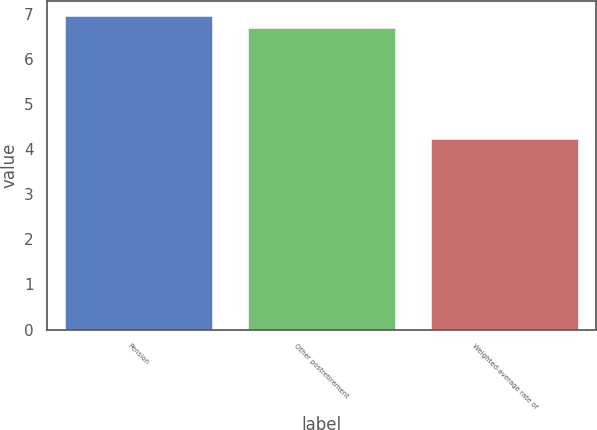Convert chart. <chart><loc_0><loc_0><loc_500><loc_500><bar_chart><fcel>Pension<fcel>Other postretirement<fcel>Weighted-average rate of<nl><fcel>6.95<fcel>6.7<fcel>4.23<nl></chart> 